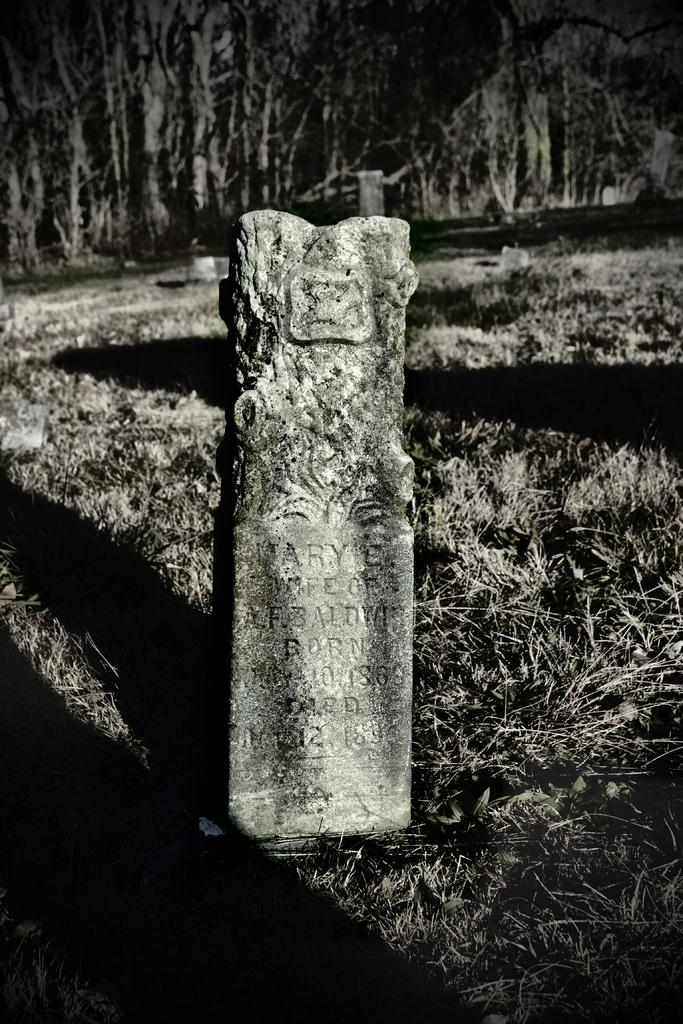What is the main subject of the image? There is a memorial in the image. What type of natural environment surrounds the memorial? There is grass in the image. What can be seen in the distance behind the memorial? There are many trees in the background of the image. What type of crown is placed on the memorial in the image? There is no crown present on the memorial in the image. What fact can be learned about the memorial from the image? The image provides information about the appearance and location of the memorial, but it does not convey any specific facts about its history or significance. 